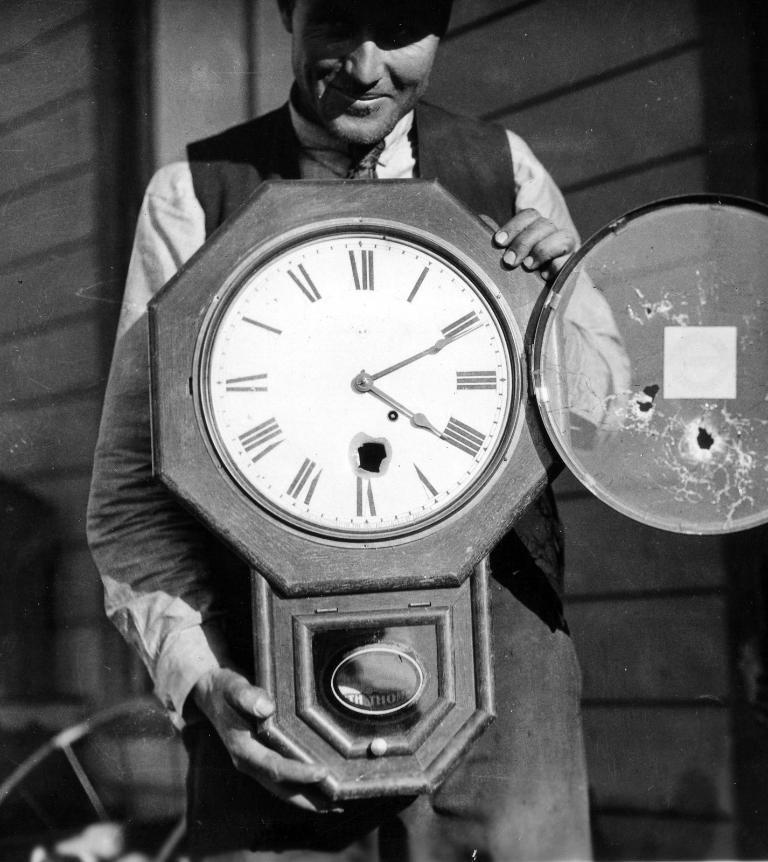<image>
Render a clear and concise summary of the photo. A man holds a wall clock that has the time displayed as 4:11. 